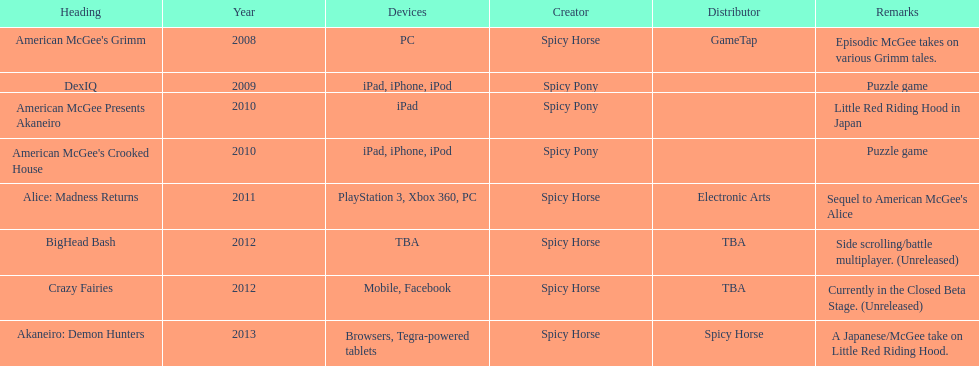What is the total number of games developed by spicy horse? 5. 